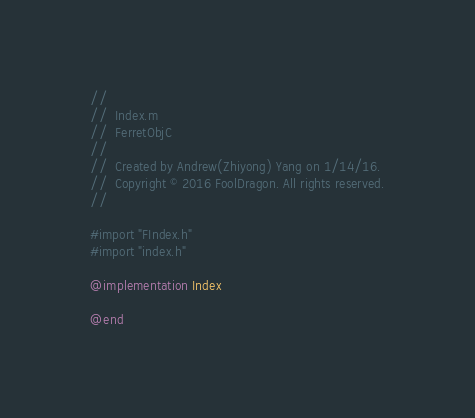<code> <loc_0><loc_0><loc_500><loc_500><_ObjectiveC_>//
//  Index.m
//  FerretObjC
//
//  Created by Andrew(Zhiyong) Yang on 1/14/16.
//  Copyright © 2016 FoolDragon. All rights reserved.
//

#import "FIndex.h"
#import "index.h"

@implementation Index

@end
</code> 